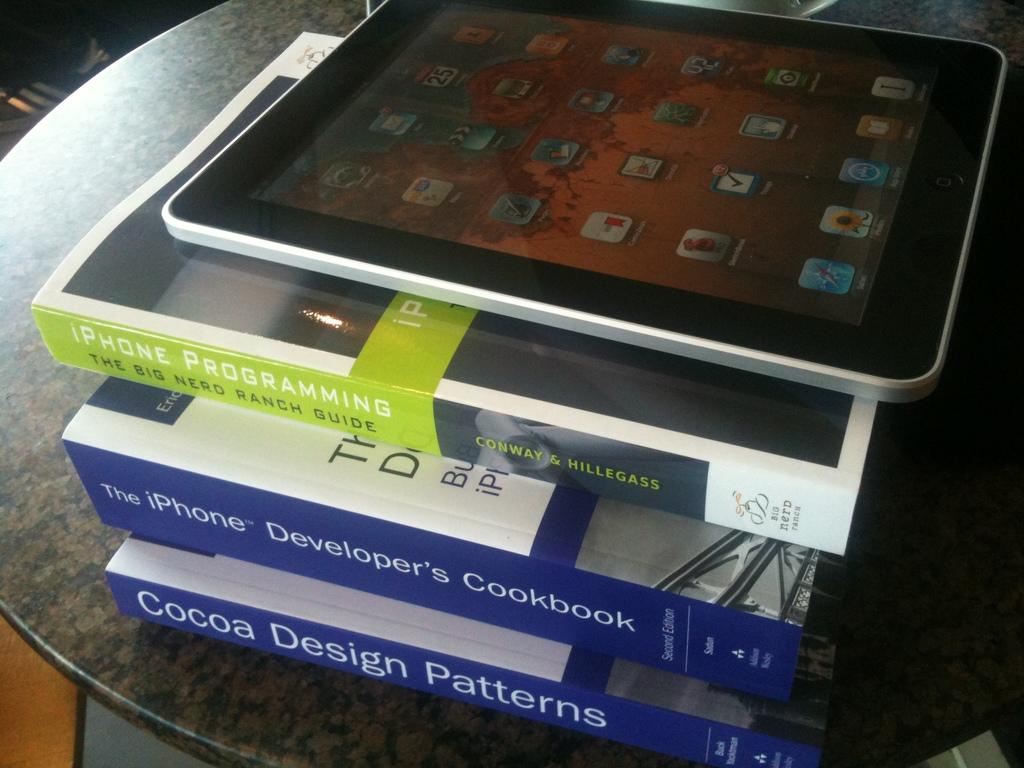Provide a one-sentence caption for the provided image. In addition to the iPad, 3 books, "iPhone Programming", "The iPhone Developer's Cookbook", and "Cocoa Design Patterns" sat on the table. 